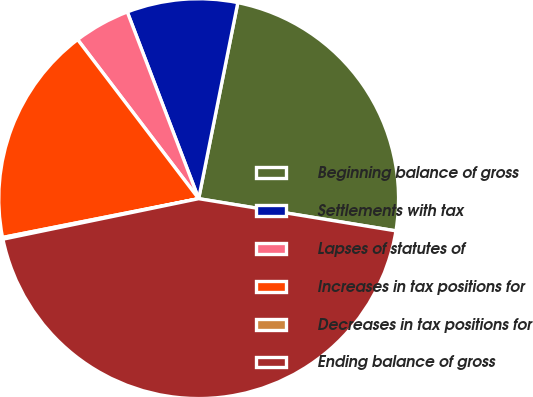<chart> <loc_0><loc_0><loc_500><loc_500><pie_chart><fcel>Beginning balance of gross<fcel>Settlements with tax<fcel>Lapses of statutes of<fcel>Increases in tax positions for<fcel>Decreases in tax positions for<fcel>Ending balance of gross<nl><fcel>24.44%<fcel>8.95%<fcel>4.54%<fcel>17.76%<fcel>0.14%<fcel>44.18%<nl></chart> 